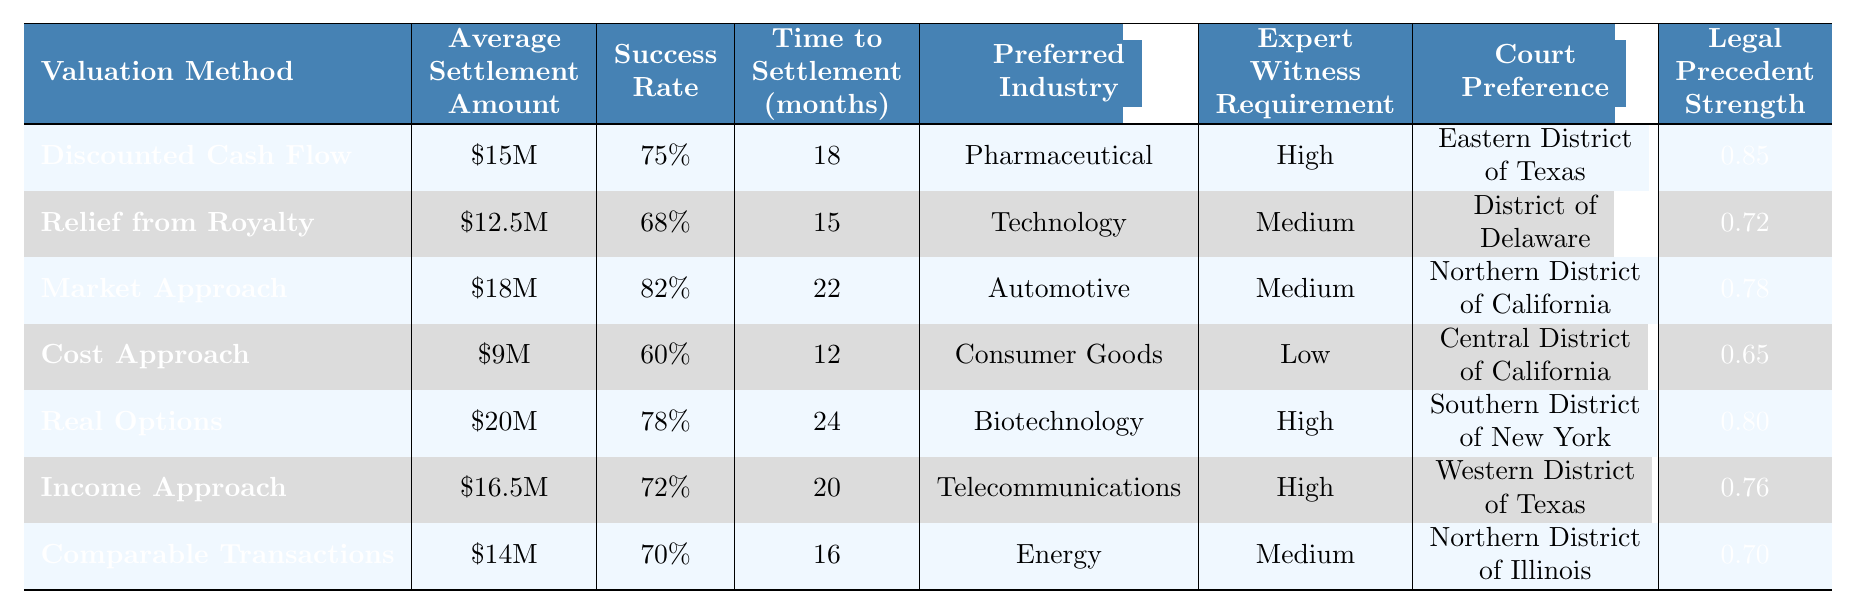What is the average settlement amount for the Market Approach? The table lists the Average Settlement Amount for each valuation method. For the Market Approach, it is specified as $18 million.
Answer: $18 million Which valuation method has the highest success rate? The table shows the Success Rate for each valuation method and highlights that the Market Approach has the highest rate at 82%.
Answer: Market Approach What is the preferred industry for the Real Options valuation method? The table includes a Preferred Industry column and states that the Real Options method is preferred in the Biotechnology industry.
Answer: Biotechnology What is the average time to settlement across all valuation methods? To find the average, sum the Time to Settlement values (18 + 15 + 22 + 12 + 24 + 20 + 16 = 127) and divide by the number of methods (7), resulting in an average of 127 / 7 = 18.14 months.
Answer: 18.14 months Is the Legal Precedent Strength of the Cost Approach greater than 0.7? Checking the Legal Precedent Strength for the Cost Approach, it is 0.65, which is less than 0.7, so the answer is false.
Answer: No Which valuation method requires a high expert witness requirement and has the highest average settlement amount? First, identify the methods with a High expert witness requirement: Discounted Cash Flow, Real Options, and Income Approach. Their average settlement amounts are $15 million, $20 million, and $16.5 million, respectively. The highest among these is Real Options at $20 million.
Answer: Real Options What is the difference in average settlement amounts between the Relief from Royalty and Cost Approach methods? The average settlement for Relief from Royalty is $12.5 million, and for Cost Approach, it is $9 million. The difference is $12.5 million - $9 million = $3.5 million.
Answer: $3.5 million What percentage of success does the Income Approach method have? The table indicates that the success rate for the Income Approach is 72%.
Answer: 72% Which court preference corresponds to the highest settlement method, and what is that amount? The method with the highest settlement amount is Real Options at $20 million, and it corresponds to the Southern District of New York for court preference.
Answer: Southern District of New York, $20 million What is the average legal precedent strength of the valuation methods that have a low expert witness requirement? The Cost Approach is the only method classified with a Low expert witness requirement, having a Legal Precedent Strength of 0.65. Thus, the average is 0.65 as there is only one method in this case.
Answer: 0.65 Which method has the lowest average settlement amount? Upon reviewing all average settlement amounts in the table, the Cost Approach has the lowest amount at $9 million.
Answer: Cost Approach 